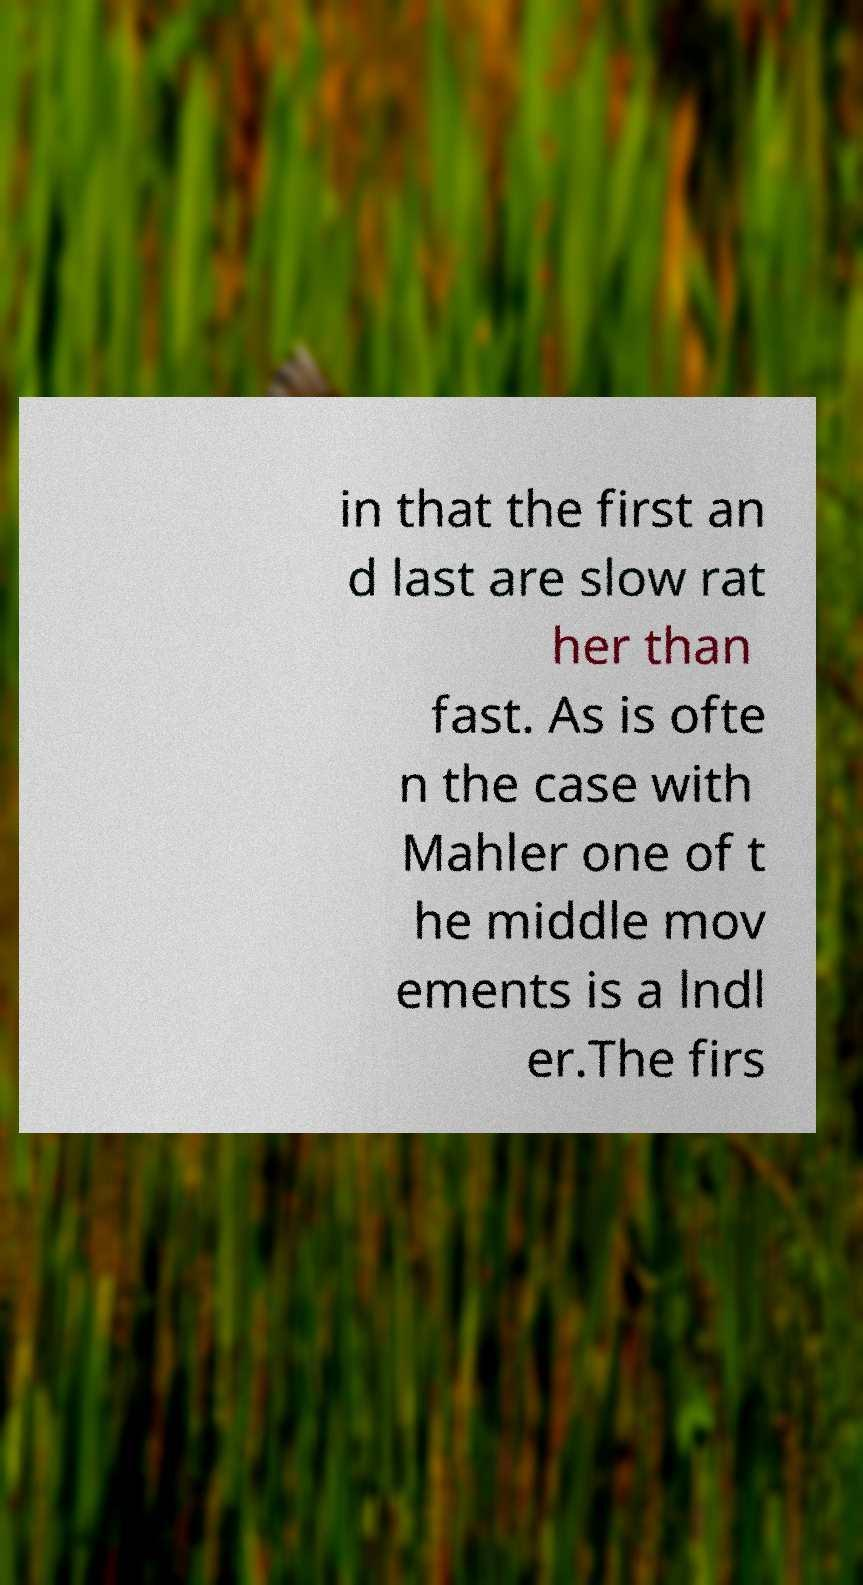Could you assist in decoding the text presented in this image and type it out clearly? in that the first an d last are slow rat her than fast. As is ofte n the case with Mahler one of t he middle mov ements is a lndl er.The firs 